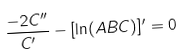<formula> <loc_0><loc_0><loc_500><loc_500>\frac { - 2 C ^ { \prime \prime } } { C ^ { \prime } } - [ \ln ( A B C ) ] ^ { \prime } = 0</formula> 